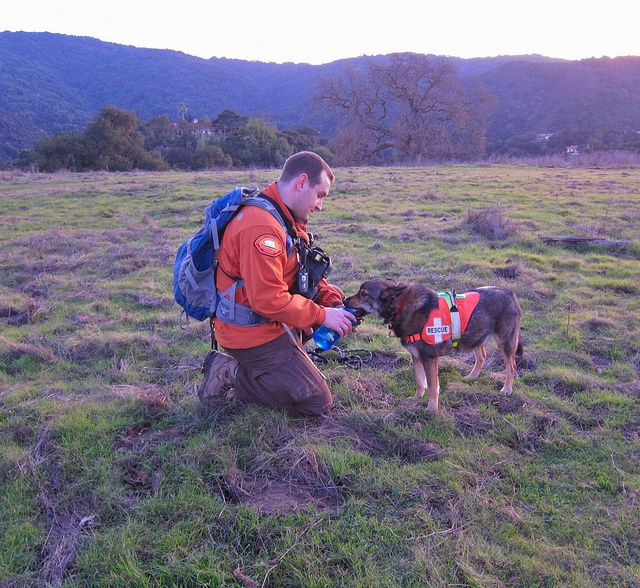Describe the objects in this image and their specific colors. I can see people in white, purple, brown, salmon, and navy tones, dog in white, purple, black, and gray tones, backpack in white, blue, navy, and darkblue tones, and bottle in white, blue, darkblue, and navy tones in this image. 